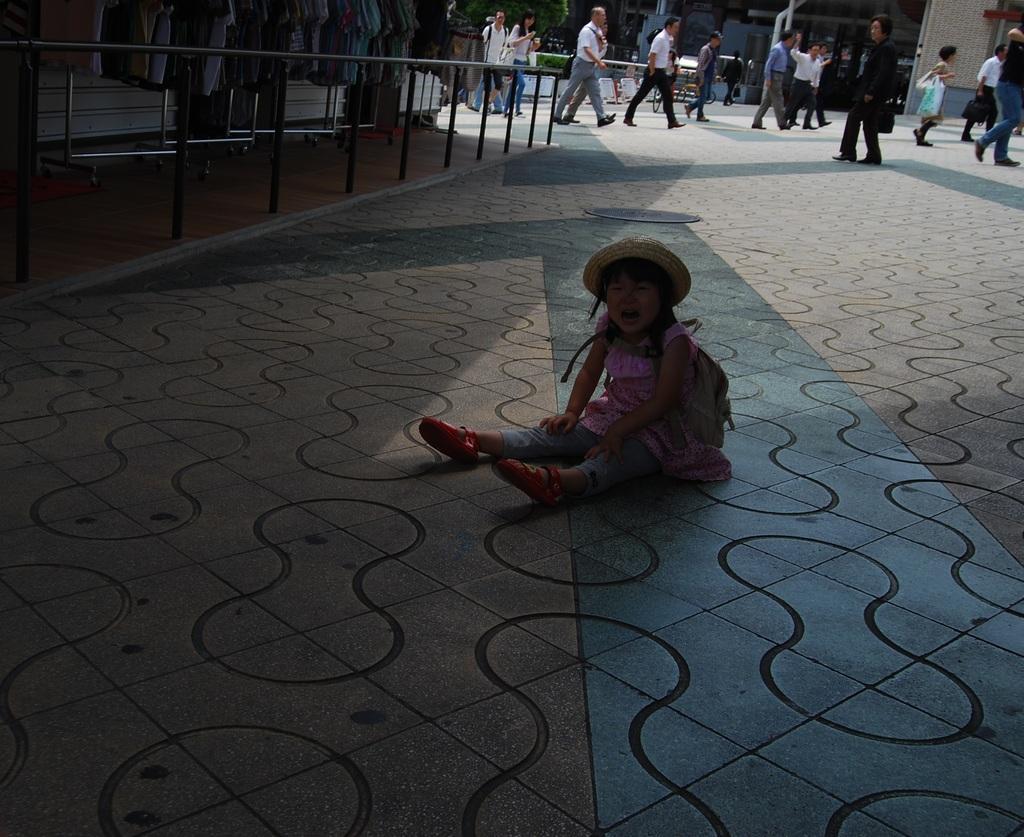Please provide a concise description of this image. At the center of the image we can see there is a little girl sat on the road. On the left side of the image there are some clothes are arranged on the rack, in front of that there is a railing. In the background there are few people walking on the road. 